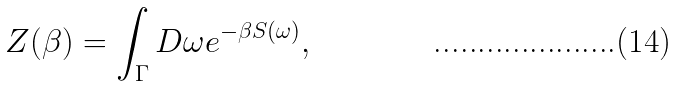Convert formula to latex. <formula><loc_0><loc_0><loc_500><loc_500>Z ( \beta ) = \int _ { \Gamma } D \omega e ^ { - \beta S ( \omega ) } ,</formula> 